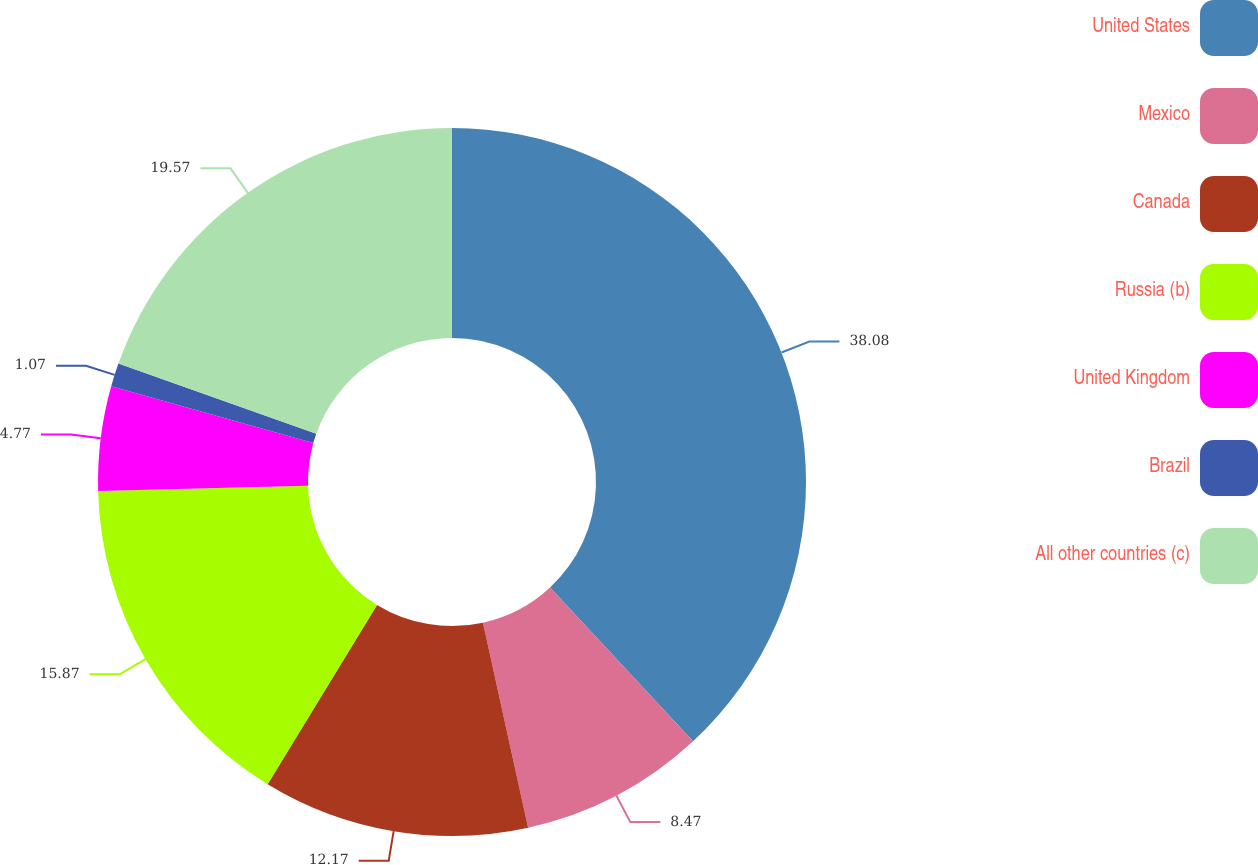Convert chart to OTSL. <chart><loc_0><loc_0><loc_500><loc_500><pie_chart><fcel>United States<fcel>Mexico<fcel>Canada<fcel>Russia (b)<fcel>United Kingdom<fcel>Brazil<fcel>All other countries (c)<nl><fcel>38.08%<fcel>8.47%<fcel>12.17%<fcel>15.87%<fcel>4.77%<fcel>1.07%<fcel>19.57%<nl></chart> 